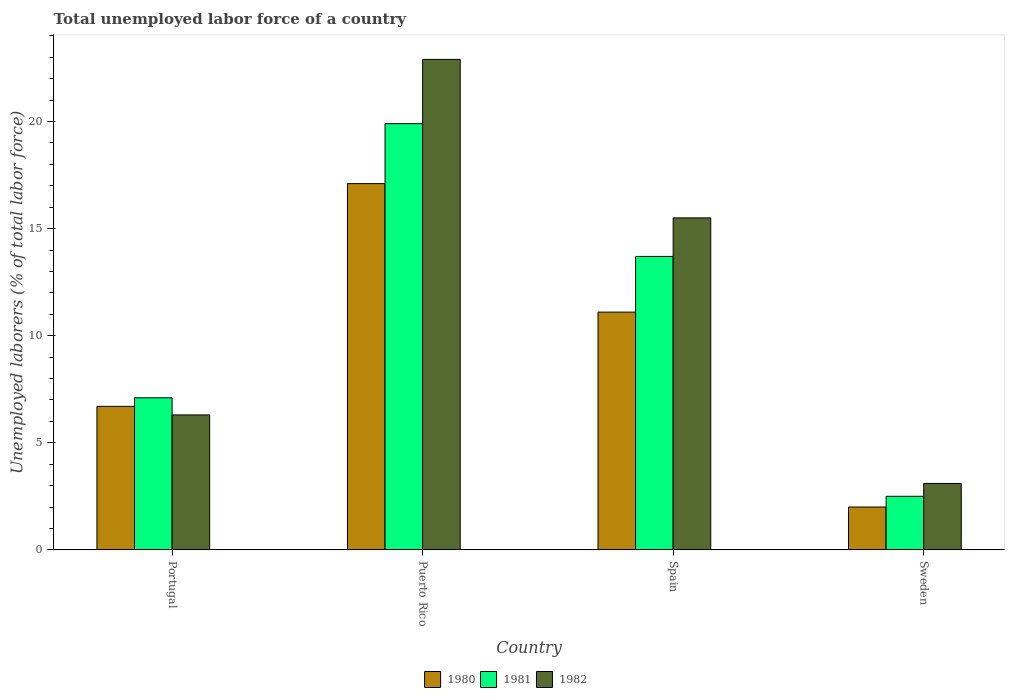How many groups of bars are there?
Ensure brevity in your answer.  4. Are the number of bars per tick equal to the number of legend labels?
Give a very brief answer. Yes. Are the number of bars on each tick of the X-axis equal?
Your answer should be compact. Yes. How many bars are there on the 2nd tick from the left?
Provide a succinct answer. 3. What is the label of the 2nd group of bars from the left?
Your answer should be compact. Puerto Rico. In how many cases, is the number of bars for a given country not equal to the number of legend labels?
Offer a terse response. 0. What is the total unemployed labor force in 1981 in Portugal?
Ensure brevity in your answer.  7.1. Across all countries, what is the maximum total unemployed labor force in 1982?
Give a very brief answer. 22.9. Across all countries, what is the minimum total unemployed labor force in 1982?
Keep it short and to the point. 3.1. In which country was the total unemployed labor force in 1980 maximum?
Give a very brief answer. Puerto Rico. In which country was the total unemployed labor force in 1981 minimum?
Give a very brief answer. Sweden. What is the total total unemployed labor force in 1982 in the graph?
Make the answer very short. 47.8. What is the difference between the total unemployed labor force in 1981 in Portugal and that in Sweden?
Your answer should be compact. 4.6. What is the difference between the total unemployed labor force in 1981 in Puerto Rico and the total unemployed labor force in 1980 in Portugal?
Give a very brief answer. 13.2. What is the average total unemployed labor force in 1981 per country?
Make the answer very short. 10.8. What is the difference between the total unemployed labor force of/in 1981 and total unemployed labor force of/in 1982 in Puerto Rico?
Provide a succinct answer. -3. What is the ratio of the total unemployed labor force in 1982 in Portugal to that in Spain?
Make the answer very short. 0.41. Is the total unemployed labor force in 1981 in Portugal less than that in Spain?
Make the answer very short. Yes. Is the difference between the total unemployed labor force in 1981 in Spain and Sweden greater than the difference between the total unemployed labor force in 1982 in Spain and Sweden?
Offer a very short reply. No. What is the difference between the highest and the second highest total unemployed labor force in 1980?
Make the answer very short. 6. What is the difference between the highest and the lowest total unemployed labor force in 1981?
Make the answer very short. 17.4. In how many countries, is the total unemployed labor force in 1980 greater than the average total unemployed labor force in 1980 taken over all countries?
Your response must be concise. 2. Is it the case that in every country, the sum of the total unemployed labor force in 1981 and total unemployed labor force in 1982 is greater than the total unemployed labor force in 1980?
Make the answer very short. Yes. How many countries are there in the graph?
Your answer should be compact. 4. What is the difference between two consecutive major ticks on the Y-axis?
Offer a very short reply. 5. Are the values on the major ticks of Y-axis written in scientific E-notation?
Your response must be concise. No. Does the graph contain grids?
Give a very brief answer. No. How many legend labels are there?
Your response must be concise. 3. What is the title of the graph?
Give a very brief answer. Total unemployed labor force of a country. What is the label or title of the X-axis?
Make the answer very short. Country. What is the label or title of the Y-axis?
Provide a succinct answer. Unemployed laborers (% of total labor force). What is the Unemployed laborers (% of total labor force) of 1980 in Portugal?
Offer a very short reply. 6.7. What is the Unemployed laborers (% of total labor force) in 1981 in Portugal?
Offer a very short reply. 7.1. What is the Unemployed laborers (% of total labor force) in 1982 in Portugal?
Offer a terse response. 6.3. What is the Unemployed laborers (% of total labor force) in 1980 in Puerto Rico?
Your answer should be compact. 17.1. What is the Unemployed laborers (% of total labor force) of 1981 in Puerto Rico?
Provide a succinct answer. 19.9. What is the Unemployed laborers (% of total labor force) in 1982 in Puerto Rico?
Your response must be concise. 22.9. What is the Unemployed laborers (% of total labor force) in 1980 in Spain?
Provide a short and direct response. 11.1. What is the Unemployed laborers (% of total labor force) of 1981 in Spain?
Offer a terse response. 13.7. What is the Unemployed laborers (% of total labor force) of 1982 in Spain?
Keep it short and to the point. 15.5. What is the Unemployed laborers (% of total labor force) of 1982 in Sweden?
Give a very brief answer. 3.1. Across all countries, what is the maximum Unemployed laborers (% of total labor force) of 1980?
Your answer should be very brief. 17.1. Across all countries, what is the maximum Unemployed laborers (% of total labor force) in 1981?
Give a very brief answer. 19.9. Across all countries, what is the maximum Unemployed laborers (% of total labor force) in 1982?
Your answer should be very brief. 22.9. Across all countries, what is the minimum Unemployed laborers (% of total labor force) of 1981?
Keep it short and to the point. 2.5. Across all countries, what is the minimum Unemployed laborers (% of total labor force) of 1982?
Make the answer very short. 3.1. What is the total Unemployed laborers (% of total labor force) in 1980 in the graph?
Your answer should be very brief. 36.9. What is the total Unemployed laborers (% of total labor force) in 1981 in the graph?
Offer a very short reply. 43.2. What is the total Unemployed laborers (% of total labor force) in 1982 in the graph?
Your answer should be very brief. 47.8. What is the difference between the Unemployed laborers (% of total labor force) of 1981 in Portugal and that in Puerto Rico?
Provide a succinct answer. -12.8. What is the difference between the Unemployed laborers (% of total labor force) of 1982 in Portugal and that in Puerto Rico?
Your answer should be compact. -16.6. What is the difference between the Unemployed laborers (% of total labor force) in 1980 in Portugal and that in Spain?
Ensure brevity in your answer.  -4.4. What is the difference between the Unemployed laborers (% of total labor force) of 1980 in Portugal and that in Sweden?
Offer a terse response. 4.7. What is the difference between the Unemployed laborers (% of total labor force) of 1982 in Portugal and that in Sweden?
Your answer should be compact. 3.2. What is the difference between the Unemployed laborers (% of total labor force) in 1980 in Puerto Rico and that in Spain?
Give a very brief answer. 6. What is the difference between the Unemployed laborers (% of total labor force) of 1981 in Puerto Rico and that in Sweden?
Provide a short and direct response. 17.4. What is the difference between the Unemployed laborers (% of total labor force) of 1982 in Puerto Rico and that in Sweden?
Offer a terse response. 19.8. What is the difference between the Unemployed laborers (% of total labor force) of 1980 in Spain and that in Sweden?
Ensure brevity in your answer.  9.1. What is the difference between the Unemployed laborers (% of total labor force) in 1982 in Spain and that in Sweden?
Ensure brevity in your answer.  12.4. What is the difference between the Unemployed laborers (% of total labor force) of 1980 in Portugal and the Unemployed laborers (% of total labor force) of 1981 in Puerto Rico?
Provide a succinct answer. -13.2. What is the difference between the Unemployed laborers (% of total labor force) of 1980 in Portugal and the Unemployed laborers (% of total labor force) of 1982 in Puerto Rico?
Provide a succinct answer. -16.2. What is the difference between the Unemployed laborers (% of total labor force) of 1981 in Portugal and the Unemployed laborers (% of total labor force) of 1982 in Puerto Rico?
Keep it short and to the point. -15.8. What is the difference between the Unemployed laborers (% of total labor force) of 1980 in Portugal and the Unemployed laborers (% of total labor force) of 1981 in Sweden?
Your answer should be compact. 4.2. What is the difference between the Unemployed laborers (% of total labor force) in 1980 in Portugal and the Unemployed laborers (% of total labor force) in 1982 in Sweden?
Offer a very short reply. 3.6. What is the difference between the Unemployed laborers (% of total labor force) of 1981 in Portugal and the Unemployed laborers (% of total labor force) of 1982 in Sweden?
Give a very brief answer. 4. What is the difference between the Unemployed laborers (% of total labor force) in 1980 in Puerto Rico and the Unemployed laborers (% of total labor force) in 1981 in Spain?
Ensure brevity in your answer.  3.4. What is the difference between the Unemployed laborers (% of total labor force) in 1980 in Puerto Rico and the Unemployed laborers (% of total labor force) in 1982 in Spain?
Give a very brief answer. 1.6. What is the difference between the Unemployed laborers (% of total labor force) of 1980 in Puerto Rico and the Unemployed laborers (% of total labor force) of 1982 in Sweden?
Provide a succinct answer. 14. What is the difference between the Unemployed laborers (% of total labor force) in 1980 in Spain and the Unemployed laborers (% of total labor force) in 1981 in Sweden?
Keep it short and to the point. 8.6. What is the difference between the Unemployed laborers (% of total labor force) of 1980 in Spain and the Unemployed laborers (% of total labor force) of 1982 in Sweden?
Provide a short and direct response. 8. What is the difference between the Unemployed laborers (% of total labor force) in 1981 in Spain and the Unemployed laborers (% of total labor force) in 1982 in Sweden?
Make the answer very short. 10.6. What is the average Unemployed laborers (% of total labor force) in 1980 per country?
Offer a terse response. 9.22. What is the average Unemployed laborers (% of total labor force) of 1981 per country?
Your answer should be very brief. 10.8. What is the average Unemployed laborers (% of total labor force) of 1982 per country?
Keep it short and to the point. 11.95. What is the difference between the Unemployed laborers (% of total labor force) in 1980 and Unemployed laborers (% of total labor force) in 1981 in Portugal?
Offer a very short reply. -0.4. What is the difference between the Unemployed laborers (% of total labor force) in 1980 and Unemployed laborers (% of total labor force) in 1982 in Portugal?
Provide a short and direct response. 0.4. What is the difference between the Unemployed laborers (% of total labor force) of 1981 and Unemployed laborers (% of total labor force) of 1982 in Portugal?
Make the answer very short. 0.8. What is the difference between the Unemployed laborers (% of total labor force) of 1980 and Unemployed laborers (% of total labor force) of 1982 in Puerto Rico?
Provide a short and direct response. -5.8. What is the difference between the Unemployed laborers (% of total labor force) of 1980 and Unemployed laborers (% of total labor force) of 1982 in Spain?
Keep it short and to the point. -4.4. What is the difference between the Unemployed laborers (% of total labor force) of 1981 and Unemployed laborers (% of total labor force) of 1982 in Sweden?
Ensure brevity in your answer.  -0.6. What is the ratio of the Unemployed laborers (% of total labor force) in 1980 in Portugal to that in Puerto Rico?
Keep it short and to the point. 0.39. What is the ratio of the Unemployed laborers (% of total labor force) in 1981 in Portugal to that in Puerto Rico?
Your response must be concise. 0.36. What is the ratio of the Unemployed laborers (% of total labor force) in 1982 in Portugal to that in Puerto Rico?
Your answer should be very brief. 0.28. What is the ratio of the Unemployed laborers (% of total labor force) of 1980 in Portugal to that in Spain?
Provide a succinct answer. 0.6. What is the ratio of the Unemployed laborers (% of total labor force) of 1981 in Portugal to that in Spain?
Provide a short and direct response. 0.52. What is the ratio of the Unemployed laborers (% of total labor force) in 1982 in Portugal to that in Spain?
Offer a terse response. 0.41. What is the ratio of the Unemployed laborers (% of total labor force) in 1980 in Portugal to that in Sweden?
Offer a very short reply. 3.35. What is the ratio of the Unemployed laborers (% of total labor force) of 1981 in Portugal to that in Sweden?
Your response must be concise. 2.84. What is the ratio of the Unemployed laborers (% of total labor force) in 1982 in Portugal to that in Sweden?
Offer a terse response. 2.03. What is the ratio of the Unemployed laborers (% of total labor force) of 1980 in Puerto Rico to that in Spain?
Your answer should be compact. 1.54. What is the ratio of the Unemployed laborers (% of total labor force) in 1981 in Puerto Rico to that in Spain?
Your answer should be very brief. 1.45. What is the ratio of the Unemployed laborers (% of total labor force) of 1982 in Puerto Rico to that in Spain?
Provide a succinct answer. 1.48. What is the ratio of the Unemployed laborers (% of total labor force) of 1980 in Puerto Rico to that in Sweden?
Provide a short and direct response. 8.55. What is the ratio of the Unemployed laborers (% of total labor force) of 1981 in Puerto Rico to that in Sweden?
Ensure brevity in your answer.  7.96. What is the ratio of the Unemployed laborers (% of total labor force) in 1982 in Puerto Rico to that in Sweden?
Offer a terse response. 7.39. What is the ratio of the Unemployed laborers (% of total labor force) of 1980 in Spain to that in Sweden?
Provide a short and direct response. 5.55. What is the ratio of the Unemployed laborers (% of total labor force) of 1981 in Spain to that in Sweden?
Provide a succinct answer. 5.48. What is the difference between the highest and the second highest Unemployed laborers (% of total labor force) in 1980?
Give a very brief answer. 6. What is the difference between the highest and the lowest Unemployed laborers (% of total labor force) in 1982?
Ensure brevity in your answer.  19.8. 